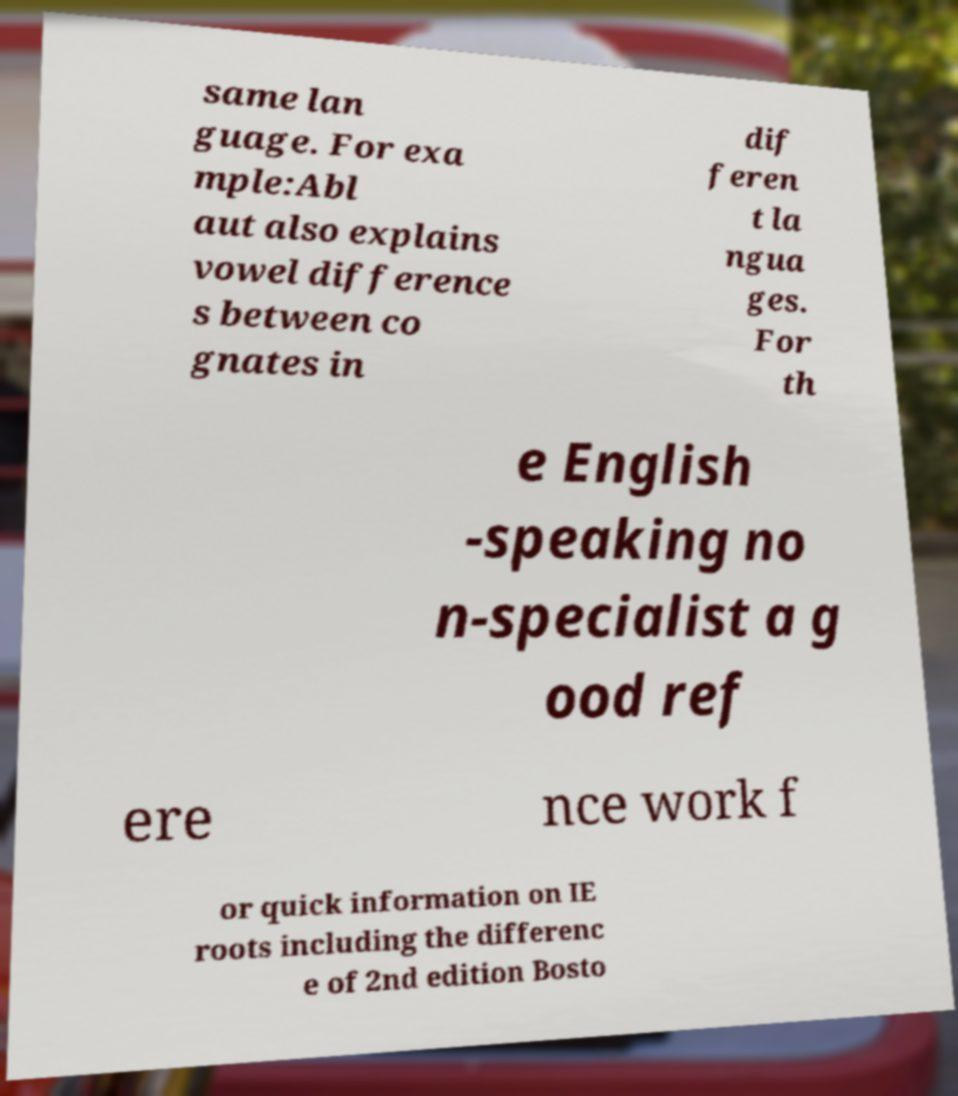Please read and relay the text visible in this image. What does it say? same lan guage. For exa mple:Abl aut also explains vowel difference s between co gnates in dif feren t la ngua ges. For th e English -speaking no n-specialist a g ood ref ere nce work f or quick information on IE roots including the differenc e of 2nd edition Bosto 